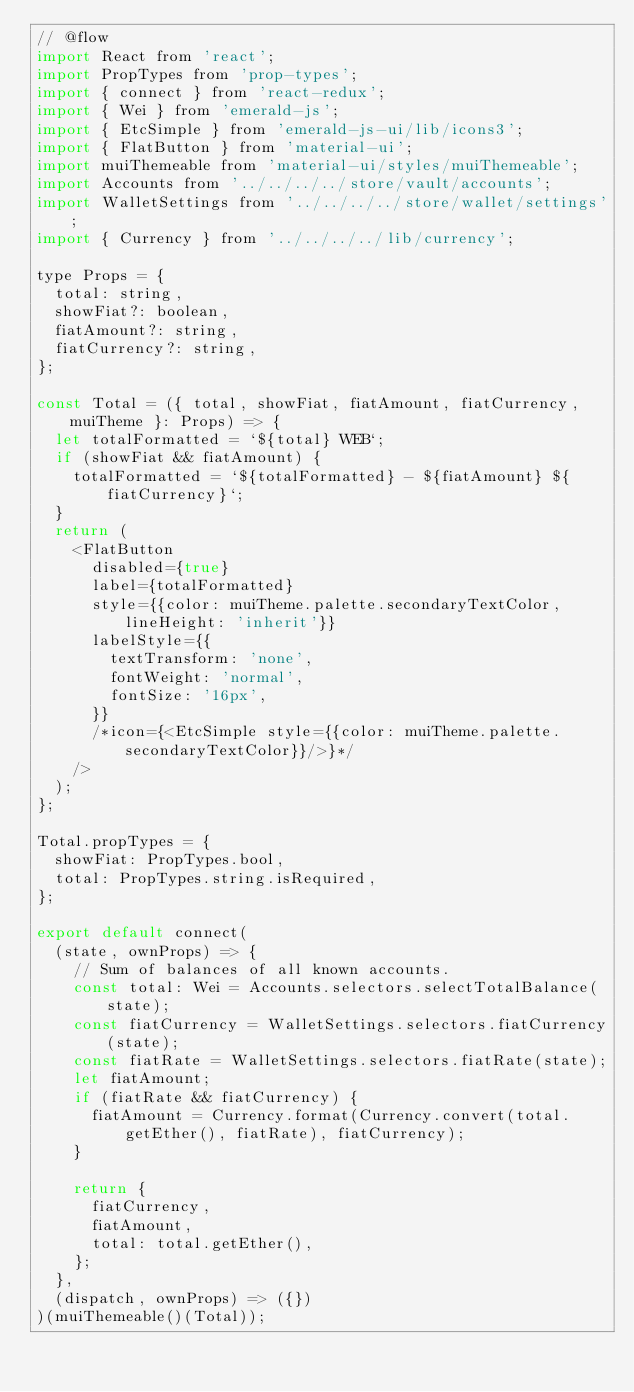Convert code to text. <code><loc_0><loc_0><loc_500><loc_500><_JavaScript_>// @flow
import React from 'react';
import PropTypes from 'prop-types';
import { connect } from 'react-redux';
import { Wei } from 'emerald-js';
import { EtcSimple } from 'emerald-js-ui/lib/icons3';
import { FlatButton } from 'material-ui';
import muiThemeable from 'material-ui/styles/muiThemeable';
import Accounts from '../../../../store/vault/accounts';
import WalletSettings from '../../../../store/wallet/settings';
import { Currency } from '../../../../lib/currency';

type Props = {
  total: string,
  showFiat?: boolean,
  fiatAmount?: string,
  fiatCurrency?: string,
};

const Total = ({ total, showFiat, fiatAmount, fiatCurrency, muiTheme }: Props) => {
  let totalFormatted = `${total} WEB`;
  if (showFiat && fiatAmount) {
    totalFormatted = `${totalFormatted} - ${fiatAmount} ${fiatCurrency}`;
  }
  return (
    <FlatButton
      disabled={true}
      label={totalFormatted}
      style={{color: muiTheme.palette.secondaryTextColor, lineHeight: 'inherit'}}
      labelStyle={{
        textTransform: 'none',
        fontWeight: 'normal',
        fontSize: '16px',
      }}
      /*icon={<EtcSimple style={{color: muiTheme.palette.secondaryTextColor}}/>}*/
    />
  );
};

Total.propTypes = {
  showFiat: PropTypes.bool,
  total: PropTypes.string.isRequired,
};

export default connect(
  (state, ownProps) => {
    // Sum of balances of all known accounts.
    const total: Wei = Accounts.selectors.selectTotalBalance(state);
    const fiatCurrency = WalletSettings.selectors.fiatCurrency(state);
    const fiatRate = WalletSettings.selectors.fiatRate(state);
    let fiatAmount;
    if (fiatRate && fiatCurrency) {
      fiatAmount = Currency.format(Currency.convert(total.getEther(), fiatRate), fiatCurrency);
    }

    return {
      fiatCurrency,
      fiatAmount,
      total: total.getEther(),
    };
  },
  (dispatch, ownProps) => ({})
)(muiThemeable()(Total));
</code> 